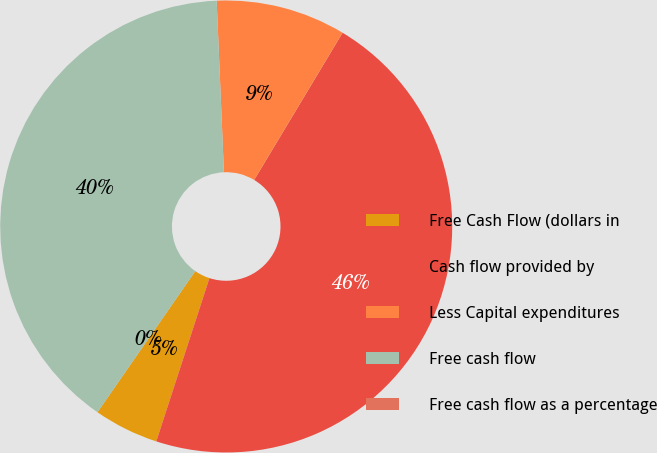<chart> <loc_0><loc_0><loc_500><loc_500><pie_chart><fcel>Free Cash Flow (dollars in<fcel>Cash flow provided by<fcel>Less Capital expenditures<fcel>Free cash flow<fcel>Free cash flow as a percentage<nl><fcel>4.64%<fcel>46.4%<fcel>9.28%<fcel>39.68%<fcel>0.0%<nl></chart> 